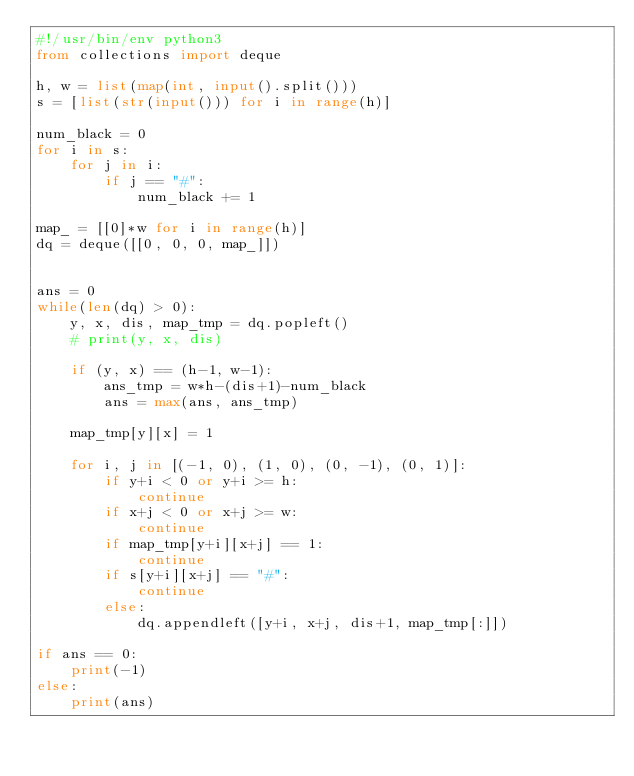<code> <loc_0><loc_0><loc_500><loc_500><_Python_>#!/usr/bin/env python3
from collections import deque

h, w = list(map(int, input().split()))
s = [list(str(input())) for i in range(h)]

num_black = 0
for i in s:
    for j in i:
        if j == "#":
            num_black += 1

map_ = [[0]*w for i in range(h)]
dq = deque([[0, 0, 0, map_]])


ans = 0
while(len(dq) > 0):
    y, x, dis, map_tmp = dq.popleft()
    # print(y, x, dis)

    if (y, x) == (h-1, w-1):
        ans_tmp = w*h-(dis+1)-num_black
        ans = max(ans, ans_tmp)

    map_tmp[y][x] = 1

    for i, j in [(-1, 0), (1, 0), (0, -1), (0, 1)]:
        if y+i < 0 or y+i >= h:
            continue
        if x+j < 0 or x+j >= w:
            continue
        if map_tmp[y+i][x+j] == 1:
            continue
        if s[y+i][x+j] == "#":
            continue
        else:
            dq.appendleft([y+i, x+j, dis+1, map_tmp[:]])

if ans == 0:
    print(-1)
else:
    print(ans)
</code> 